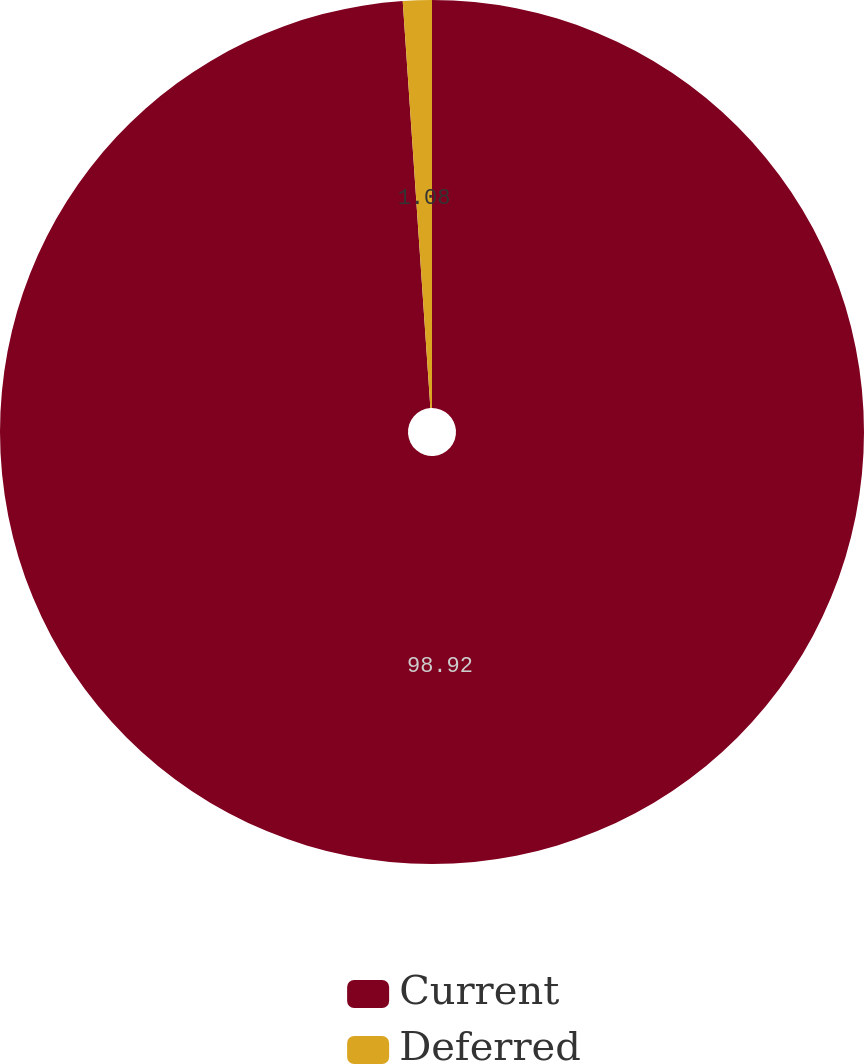<chart> <loc_0><loc_0><loc_500><loc_500><pie_chart><fcel>Current<fcel>Deferred<nl><fcel>98.92%<fcel>1.08%<nl></chart> 